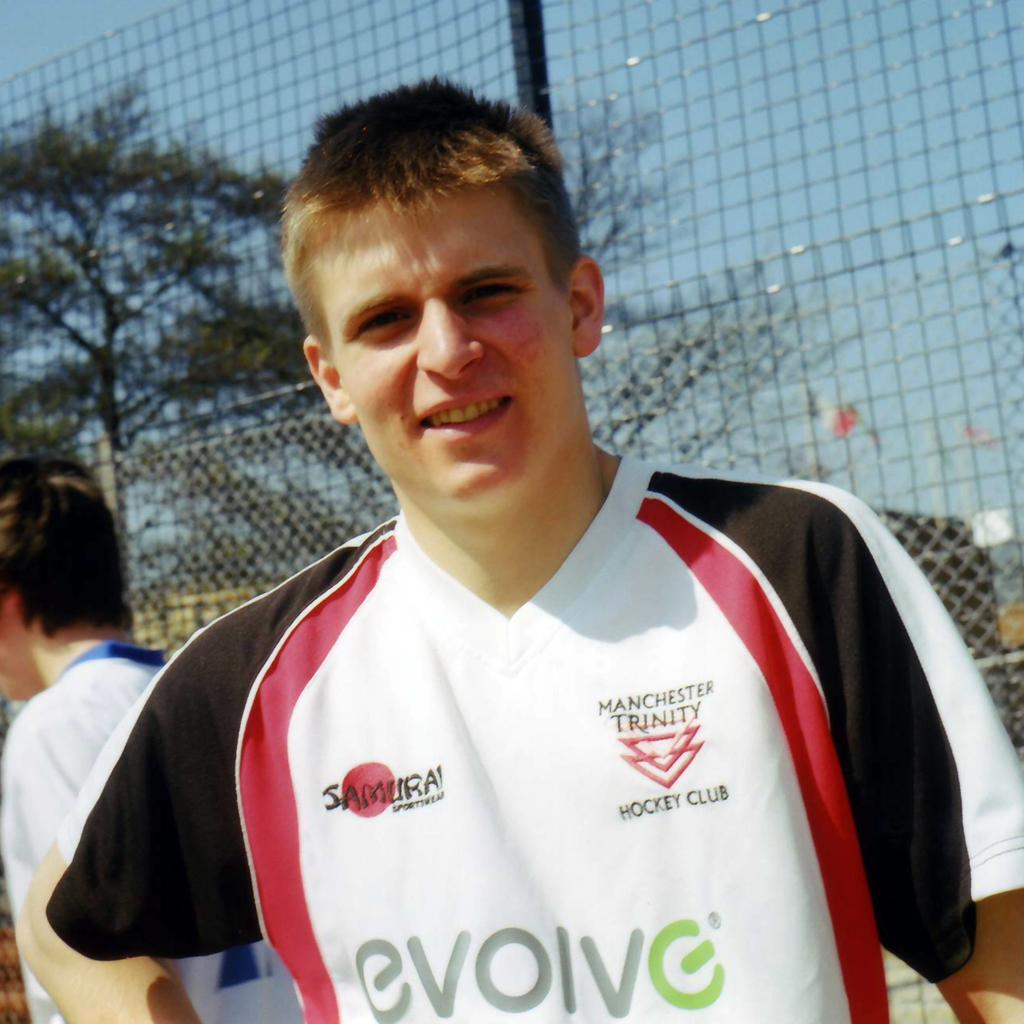<image>
Summarize the visual content of the image. Man wearing a shirt saying Evolve and it is part of Manchester Trinity Hockey Club. 